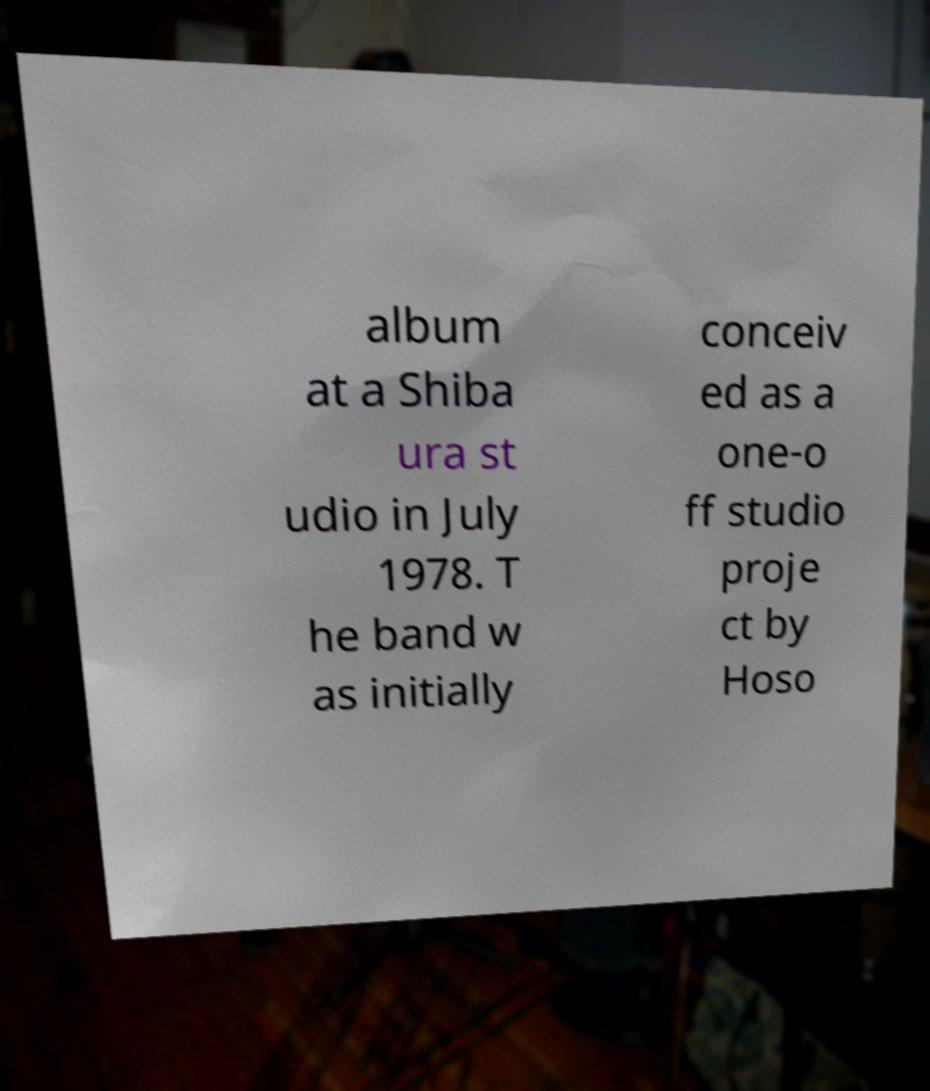Can you read and provide the text displayed in the image?This photo seems to have some interesting text. Can you extract and type it out for me? album at a Shiba ura st udio in July 1978. T he band w as initially conceiv ed as a one-o ff studio proje ct by Hoso 